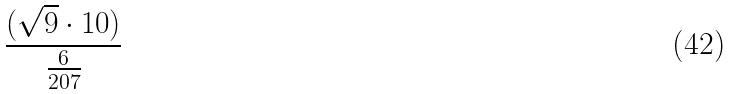<formula> <loc_0><loc_0><loc_500><loc_500>\frac { ( \sqrt { 9 } \cdot 1 0 ) } { \frac { 6 } { 2 0 7 } }</formula> 